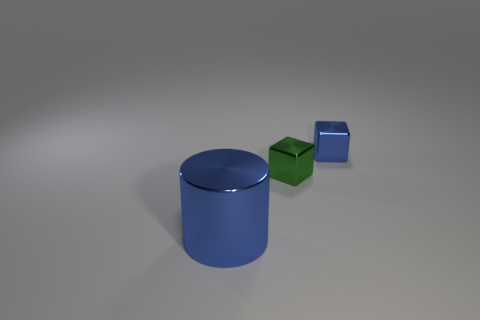Subtract 1 cylinders. How many cylinders are left? 0 Subtract all green cylinders. Subtract all red spheres. How many cylinders are left? 1 Subtract all cyan cylinders. How many blue blocks are left? 1 Subtract all big brown shiny things. Subtract all blue things. How many objects are left? 1 Add 3 small blue metal things. How many small blue metal things are left? 4 Add 3 blue metal things. How many blue metal things exist? 5 Add 3 large blue metallic objects. How many objects exist? 6 Subtract 1 blue blocks. How many objects are left? 2 Subtract all cubes. How many objects are left? 1 